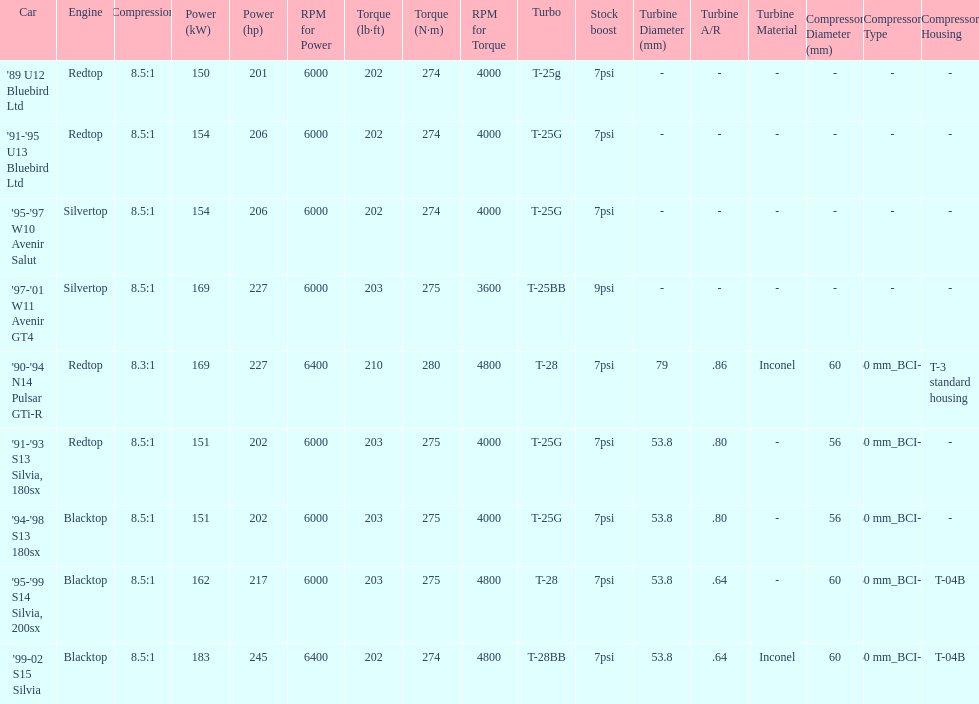Which engines are the same as the first entry ('89 u12 bluebird ltd)? '91-'95 U13 Bluebird Ltd, '90-'94 N14 Pulsar GTi-R, '91-'93 S13 Silvia, 180sx. 